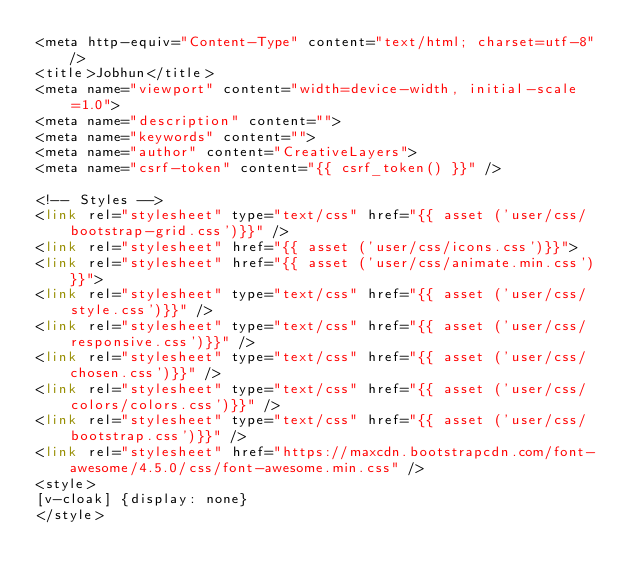<code> <loc_0><loc_0><loc_500><loc_500><_PHP_><meta http-equiv="Content-Type" content="text/html; charset=utf-8" />
<title>Jobhun</title>
<meta name="viewport" content="width=device-width, initial-scale=1.0">
<meta name="description" content="">
<meta name="keywords" content="">
<meta name="author" content="CreativeLayers">
<meta name="csrf-token" content="{{ csrf_token() }}" />

<!-- Styles -->
<link rel="stylesheet" type="text/css" href="{{ asset ('user/css/bootstrap-grid.css')}}" />
<link rel="stylesheet" href="{{ asset ('user/css/icons.css')}}">
<link rel="stylesheet" href="{{ asset ('user/css/animate.min.css')}}">
<link rel="stylesheet" type="text/css" href="{{ asset ('user/css/style.css')}}" />
<link rel="stylesheet" type="text/css" href="{{ asset ('user/css/responsive.css')}}" />
<link rel="stylesheet" type="text/css" href="{{ asset ('user/css/chosen.css')}}" />
<link rel="stylesheet" type="text/css" href="{{ asset ('user/css/colors/colors.css')}}" />
<link rel="stylesheet" type="text/css" href="{{ asset ('user/css/bootstrap.css')}}" />
<link rel="stylesheet" href="https://maxcdn.bootstrapcdn.com/font-awesome/4.5.0/css/font-awesome.min.css" />
<style>
[v-cloak] {display: none}
</style></code> 